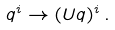Convert formula to latex. <formula><loc_0><loc_0><loc_500><loc_500>q ^ { i } \rightarrow ( U q ) ^ { i } \, .</formula> 